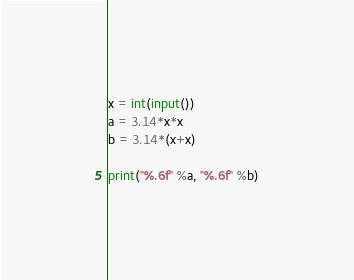<code> <loc_0><loc_0><loc_500><loc_500><_Python_>x = int(input())
a = 3.14*x*x
b = 3.14*(x+x)

print("%.6f" %a, "%.6f" %b)</code> 